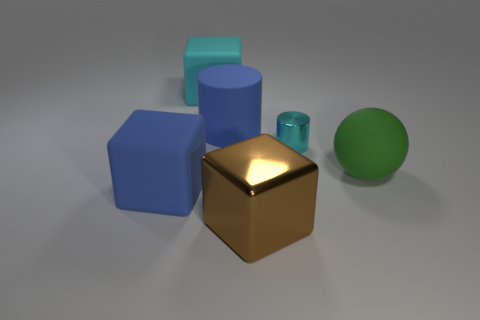Are there the same number of tiny cyan metallic cylinders that are to the left of the big blue block and large cyan things?
Offer a very short reply. No. What is the shape of the green matte object that is the same size as the cyan block?
Ensure brevity in your answer.  Sphere. How many other objects are the same shape as the brown metallic thing?
Ensure brevity in your answer.  2. Is the size of the brown metal block the same as the cylinder behind the small cylinder?
Your answer should be compact. Yes. How many things are blocks that are in front of the large cyan matte cube or large things?
Your answer should be very brief. 5. The matte thing that is to the right of the large metallic thing has what shape?
Provide a short and direct response. Sphere. Are there an equal number of large cylinders that are behind the big green rubber ball and large green matte spheres on the left side of the large blue matte cylinder?
Your answer should be very brief. No. There is a rubber object that is in front of the cyan metal cylinder and on the left side of the big green rubber ball; what is its color?
Provide a short and direct response. Blue. What is the large blue object that is in front of the big matte thing to the right of the large cylinder made of?
Provide a succinct answer. Rubber. Is the size of the cyan block the same as the blue cylinder?
Provide a short and direct response. Yes. 